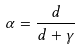<formula> <loc_0><loc_0><loc_500><loc_500>\alpha = \frac { d } { d + \gamma }</formula> 